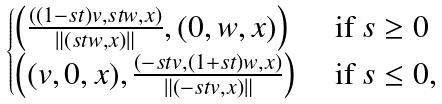<formula> <loc_0><loc_0><loc_500><loc_500>\begin{cases} \left ( \frac { ( ( 1 - s t ) v , s t w , x ) } { \| ( s t w , x ) \| } , ( 0 , w , x ) \right ) & \text { if } s \geq 0 \\ \left ( ( v , 0 , x ) , \frac { ( - s t v , ( 1 + s t ) w , x ) } { \| ( - s t v , x ) \| } \right ) & \text { if } s \leq 0 , \end{cases}</formula> 